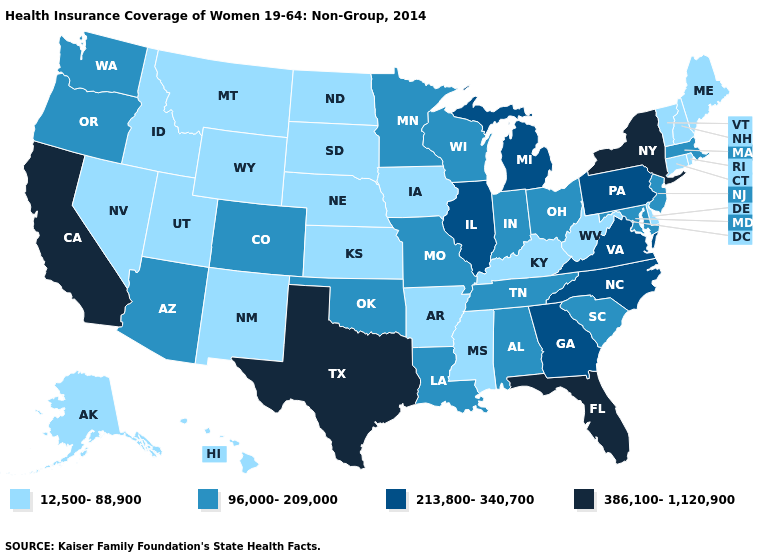What is the lowest value in states that border Florida?
Concise answer only. 96,000-209,000. What is the highest value in the South ?
Write a very short answer. 386,100-1,120,900. What is the value of Wyoming?
Quick response, please. 12,500-88,900. What is the value of Nebraska?
Concise answer only. 12,500-88,900. Name the states that have a value in the range 386,100-1,120,900?
Keep it brief. California, Florida, New York, Texas. Name the states that have a value in the range 12,500-88,900?
Concise answer only. Alaska, Arkansas, Connecticut, Delaware, Hawaii, Idaho, Iowa, Kansas, Kentucky, Maine, Mississippi, Montana, Nebraska, Nevada, New Hampshire, New Mexico, North Dakota, Rhode Island, South Dakota, Utah, Vermont, West Virginia, Wyoming. Does Montana have the lowest value in the USA?
Be succinct. Yes. Name the states that have a value in the range 213,800-340,700?
Answer briefly. Georgia, Illinois, Michigan, North Carolina, Pennsylvania, Virginia. Which states have the lowest value in the South?
Write a very short answer. Arkansas, Delaware, Kentucky, Mississippi, West Virginia. Does Mississippi have the lowest value in the USA?
Short answer required. Yes. Name the states that have a value in the range 213,800-340,700?
Quick response, please. Georgia, Illinois, Michigan, North Carolina, Pennsylvania, Virginia. What is the value of North Carolina?
Quick response, please. 213,800-340,700. What is the highest value in the South ?
Keep it brief. 386,100-1,120,900. Does Ohio have the lowest value in the USA?
Concise answer only. No. Does Alabama have the highest value in the South?
Quick response, please. No. 